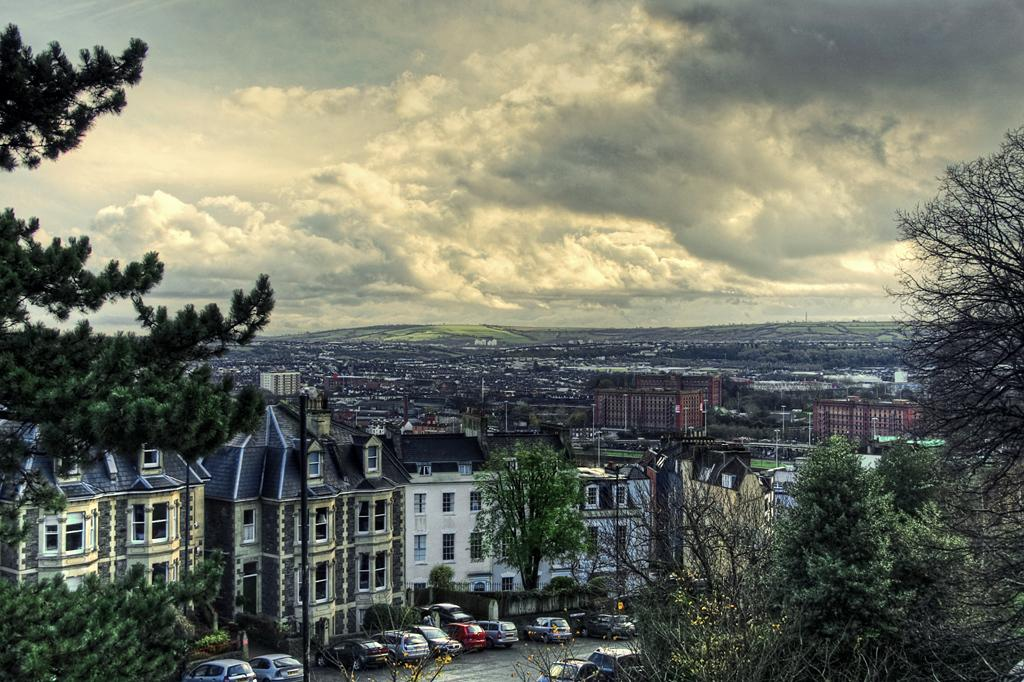What type of structures can be seen in the image? There are buildings in the image. What other natural elements are present in the image? There are trees in the image. What are the vehicles at the bottom of the image? There are vehicles at the bottom of the image. What can be seen in the sky in the image? There are clouds in the sky. What type of scent can be smelled coming from the shelf in the image? There is no shelf present in the image, so it is not possible to determine what scent might be smelled. 